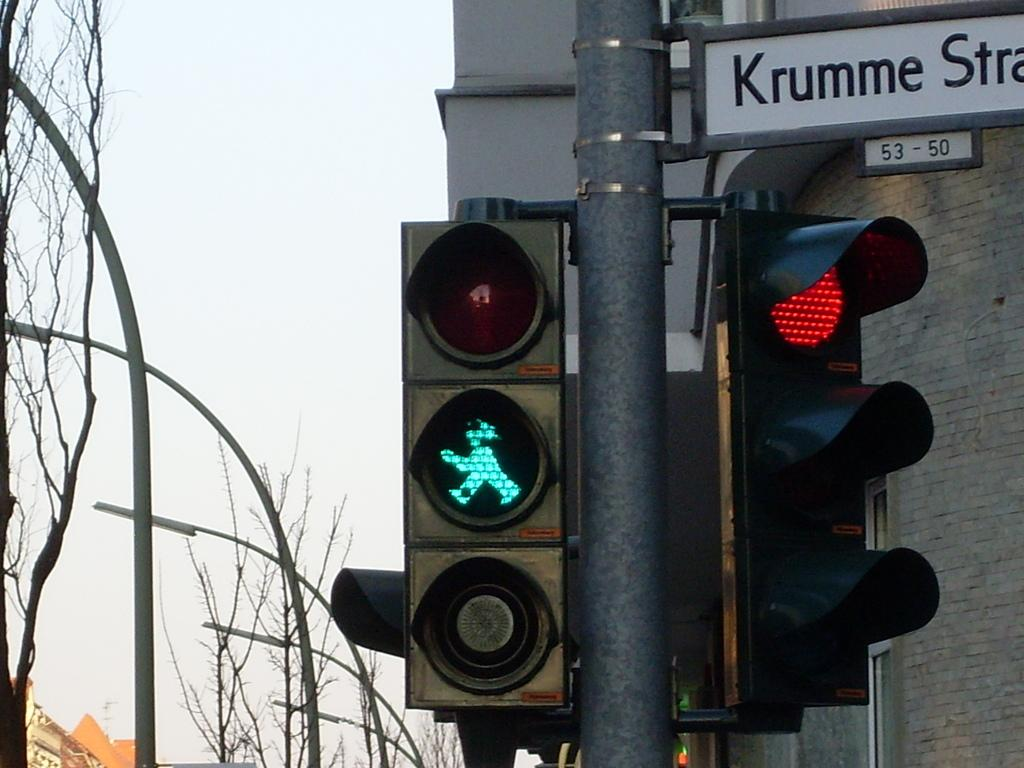Provide a one-sentence caption for the provided image. A green crosswalk light next to a street sight that starts with Krumme. 